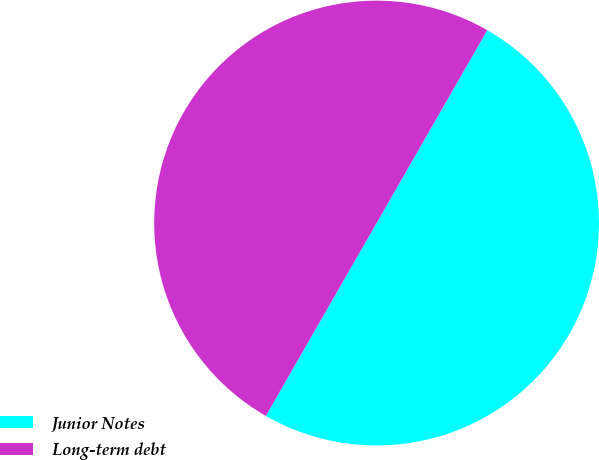Convert chart. <chart><loc_0><loc_0><loc_500><loc_500><pie_chart><fcel>Junior Notes<fcel>Long-term debt<nl><fcel>50.0%<fcel>50.0%<nl></chart> 